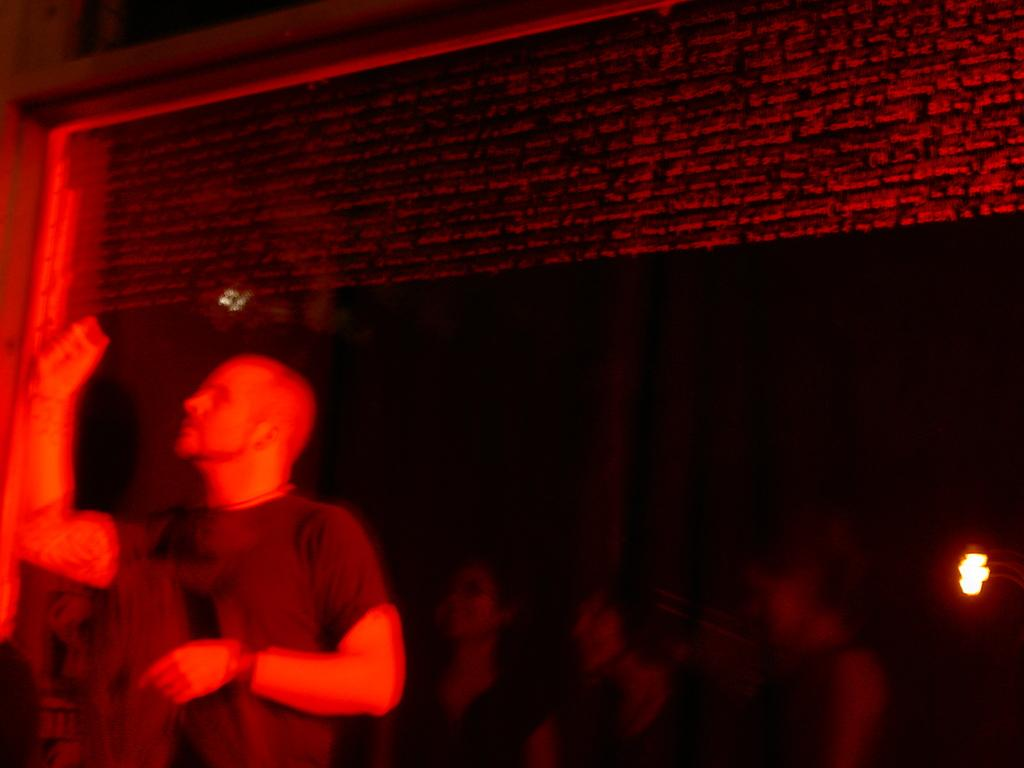Where was the image taken? The image was taken indoors. Can you describe the person on the left side of the image? There is a person standing on the left side of the image. What can be seen in the background of the image? There is a group of persons and a light visible in the background of the image. What is present at the top of the image? There are objects present at the top of the image. What type of rings can be seen on the person's fingers in the image? There are no rings visible on the person's fingers in the image. How does the heat affect the person standing on the left side of the image? The image does not provide any information about heat, so it cannot be determined how it affects the person. 